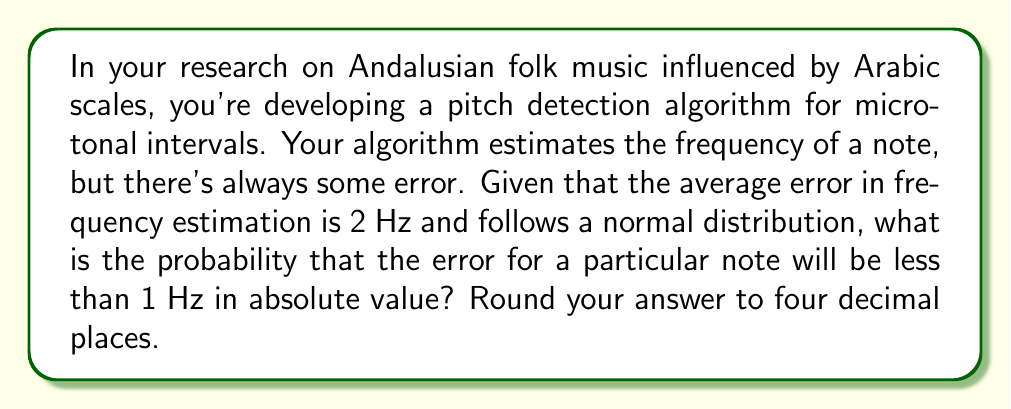What is the answer to this math problem? To solve this problem, we need to use the properties of the normal distribution and the concept of standardization.

1) First, we need to identify the parameters of our normal distribution:
   Mean (μ) = 0 (since the average error is centered around 0)
   Standard deviation (σ) = 2 Hz

2) We want to find P(|X| < 1), where X is the error in Hz.
   This is equivalent to P(-1 < X < 1)

3) To use the standard normal distribution table, we need to standardize these values:
   Z = (X - μ) / σ
   For X = 1: Z = (1 - 0) / 2 = 0.5
   For X = -1: Z = (-1 - 0) / 2 = -0.5

4) Now we need to find P(-0.5 < Z < 0.5)

5) Using the symmetry of the normal distribution:
   P(-0.5 < Z < 0.5) = P(Z < 0.5) - P(Z < -0.5)
                     = P(Z < 0.5) - (1 - P(Z < 0.5))
                     = 2P(Z < 0.5) - 1

6) From a standard normal distribution table:
   P(Z < 0.5) ≈ 0.6915

7) Therefore:
   P(-0.5 < Z < 0.5) = 2(0.6915) - 1 = 0.3830

Rounding to four decimal places gives us 0.3830.
Answer: 0.3830 